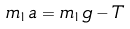Convert formula to latex. <formula><loc_0><loc_0><loc_500><loc_500>m _ { 1 } a = m _ { 1 } g - T</formula> 